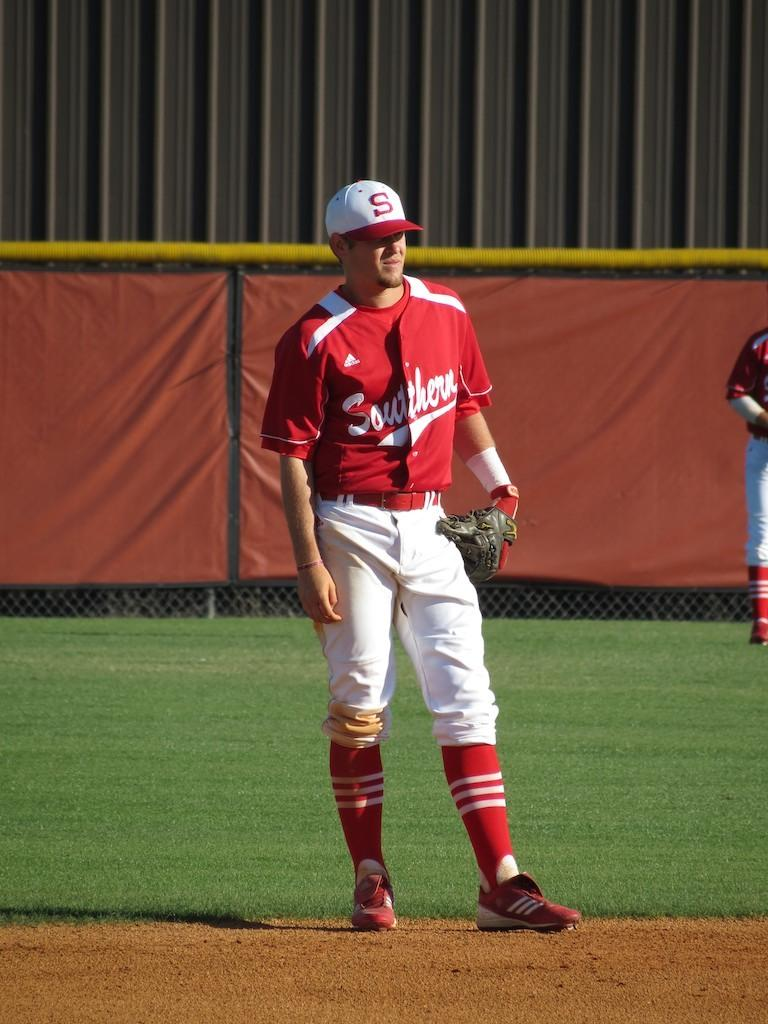Provide a one-sentence caption for the provided image. Adidas is the brand of uniform baseball team, Southern, wears. 